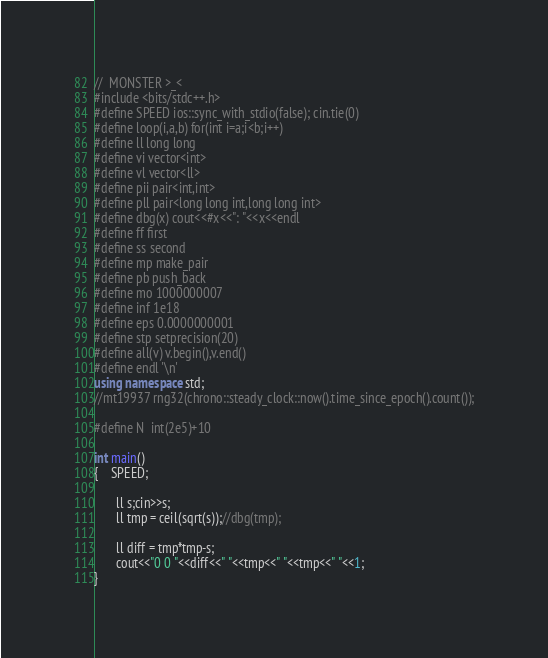<code> <loc_0><loc_0><loc_500><loc_500><_C++_>//  MONSTER >_<
#include <bits/stdc++.h>
#define SPEED ios::sync_with_stdio(false); cin.tie(0)
#define loop(i,a,b) for(int i=a;i<b;i++)
#define ll long long
#define vi vector<int>
#define vl vector<ll>
#define pii pair<int,int>
#define pll pair<long long int,long long int>
#define dbg(x) cout<<#x<<": "<<x<<endl
#define ff first
#define ss second
#define mp make_pair
#define pb push_back
#define mo 1000000007
#define inf 1e18
#define eps 0.0000000001
#define stp setprecision(20)
#define all(v) v.begin(),v.end()
#define endl '\n'
using namespace std;
//mt19937 rng32(chrono::steady_clock::now().time_since_epoch().count());

#define N  int(2e5)+10

int main()
{    SPEED;

       ll s;cin>>s;
       ll tmp = ceil(sqrt(s));//dbg(tmp);
       
       ll diff = tmp*tmp-s;
       cout<<"0 0 "<<diff<<" "<<tmp<<" "<<tmp<<" "<<1;
}

</code> 